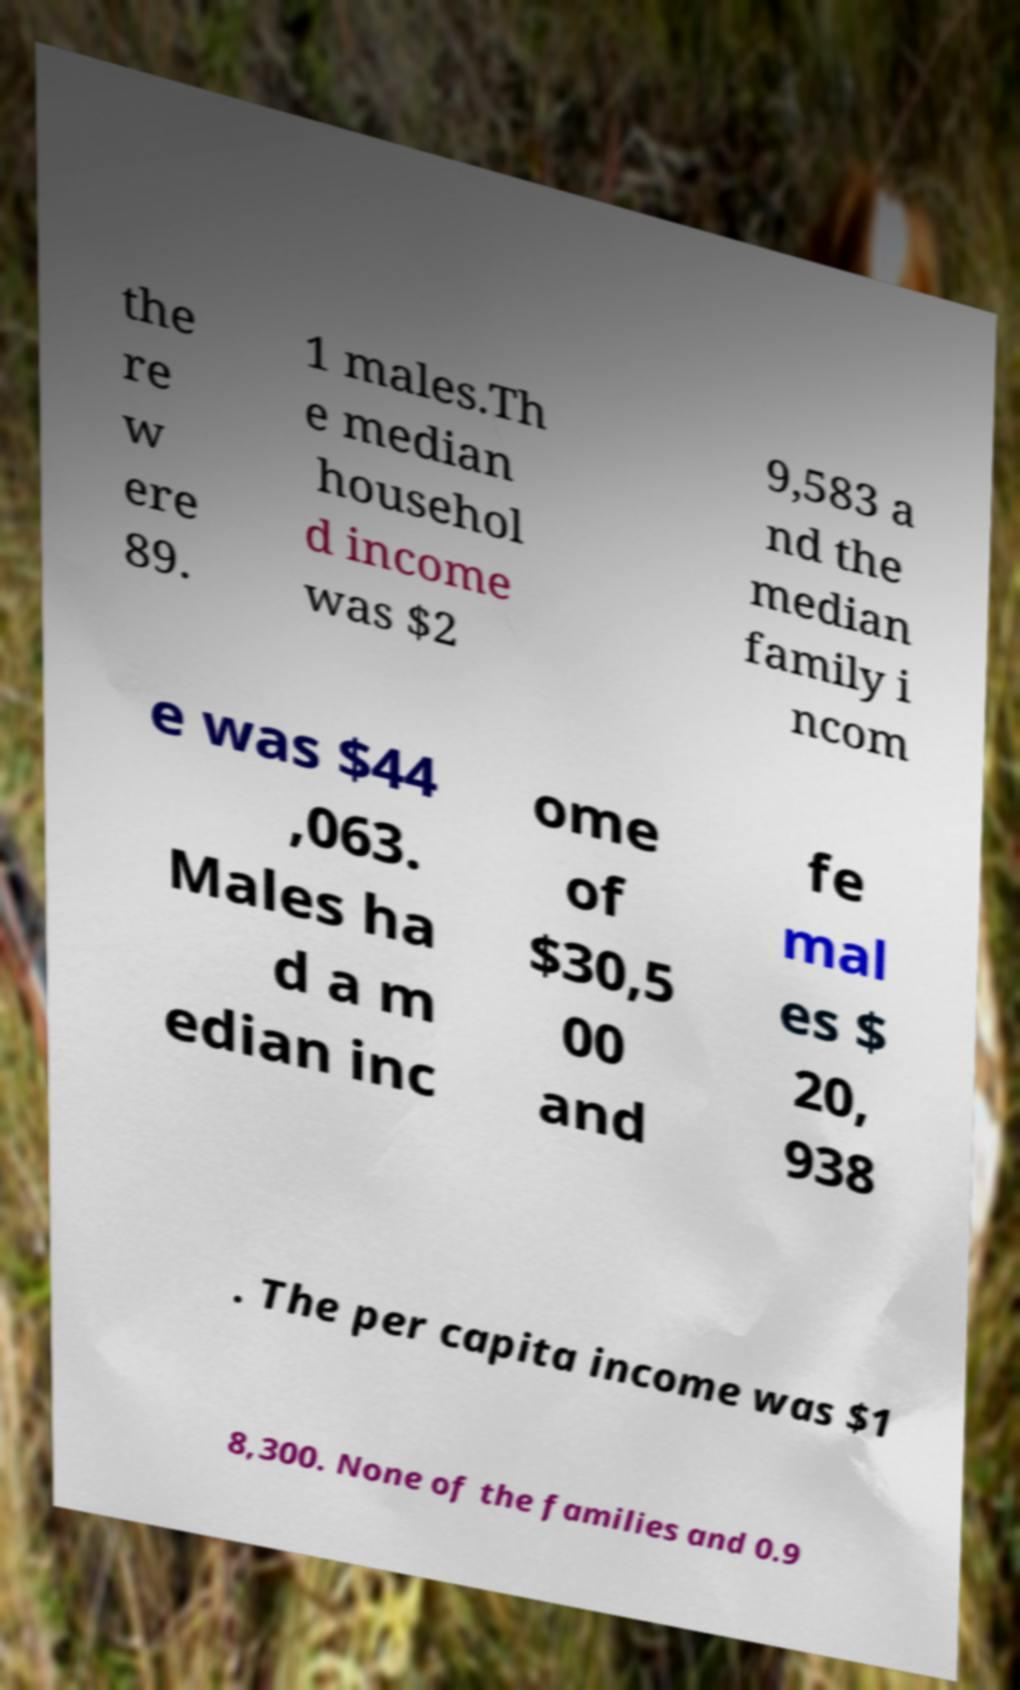Can you read and provide the text displayed in the image?This photo seems to have some interesting text. Can you extract and type it out for me? the re w ere 89. 1 males.Th e median househol d income was $2 9,583 a nd the median family i ncom e was $44 ,063. Males ha d a m edian inc ome of $30,5 00 and fe mal es $ 20, 938 . The per capita income was $1 8,300. None of the families and 0.9 